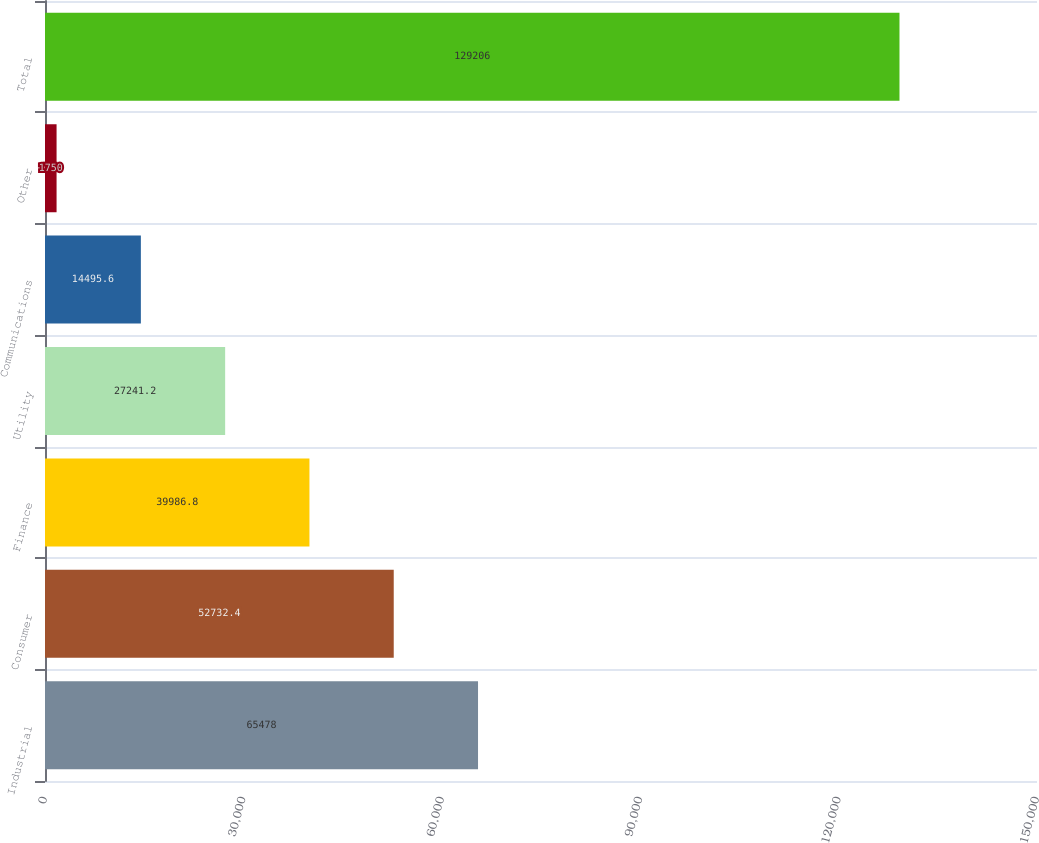Convert chart to OTSL. <chart><loc_0><loc_0><loc_500><loc_500><bar_chart><fcel>Industrial<fcel>Consumer<fcel>Finance<fcel>Utility<fcel>Communications<fcel>Other<fcel>Total<nl><fcel>65478<fcel>52732.4<fcel>39986.8<fcel>27241.2<fcel>14495.6<fcel>1750<fcel>129206<nl></chart> 